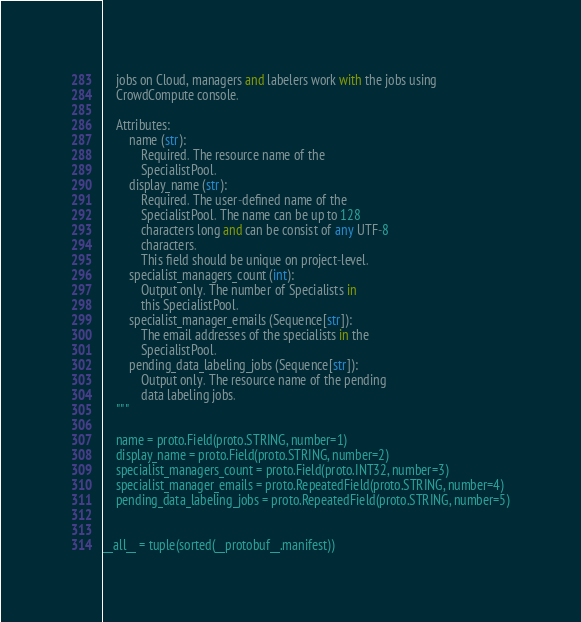Convert code to text. <code><loc_0><loc_0><loc_500><loc_500><_Python_>    jobs on Cloud, managers and labelers work with the jobs using
    CrowdCompute console.

    Attributes:
        name (str):
            Required. The resource name of the
            SpecialistPool.
        display_name (str):
            Required. The user-defined name of the
            SpecialistPool. The name can be up to 128
            characters long and can be consist of any UTF-8
            characters.
            This field should be unique on project-level.
        specialist_managers_count (int):
            Output only. The number of Specialists in
            this SpecialistPool.
        specialist_manager_emails (Sequence[str]):
            The email addresses of the specialists in the
            SpecialistPool.
        pending_data_labeling_jobs (Sequence[str]):
            Output only. The resource name of the pending
            data labeling jobs.
    """

    name = proto.Field(proto.STRING, number=1)
    display_name = proto.Field(proto.STRING, number=2)
    specialist_managers_count = proto.Field(proto.INT32, number=3)
    specialist_manager_emails = proto.RepeatedField(proto.STRING, number=4)
    pending_data_labeling_jobs = proto.RepeatedField(proto.STRING, number=5)


__all__ = tuple(sorted(__protobuf__.manifest))
</code> 